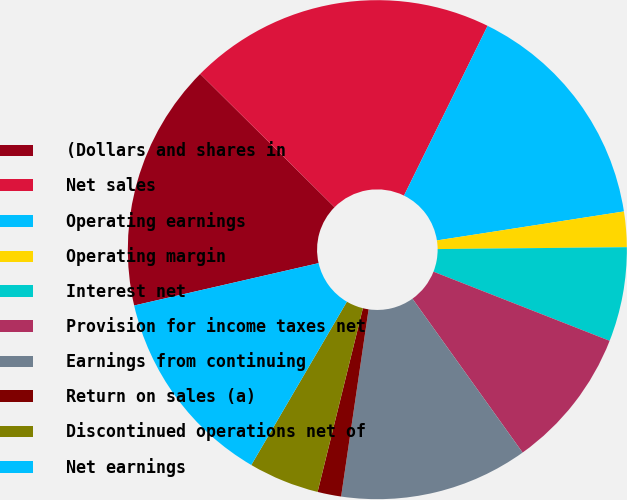<chart> <loc_0><loc_0><loc_500><loc_500><pie_chart><fcel>(Dollars and shares in<fcel>Net sales<fcel>Operating earnings<fcel>Operating margin<fcel>Interest net<fcel>Provision for income taxes net<fcel>Earnings from continuing<fcel>Return on sales (a)<fcel>Discontinued operations net of<fcel>Net earnings<nl><fcel>16.03%<fcel>19.85%<fcel>15.27%<fcel>2.29%<fcel>6.11%<fcel>9.16%<fcel>12.21%<fcel>1.53%<fcel>4.58%<fcel>12.98%<nl></chart> 